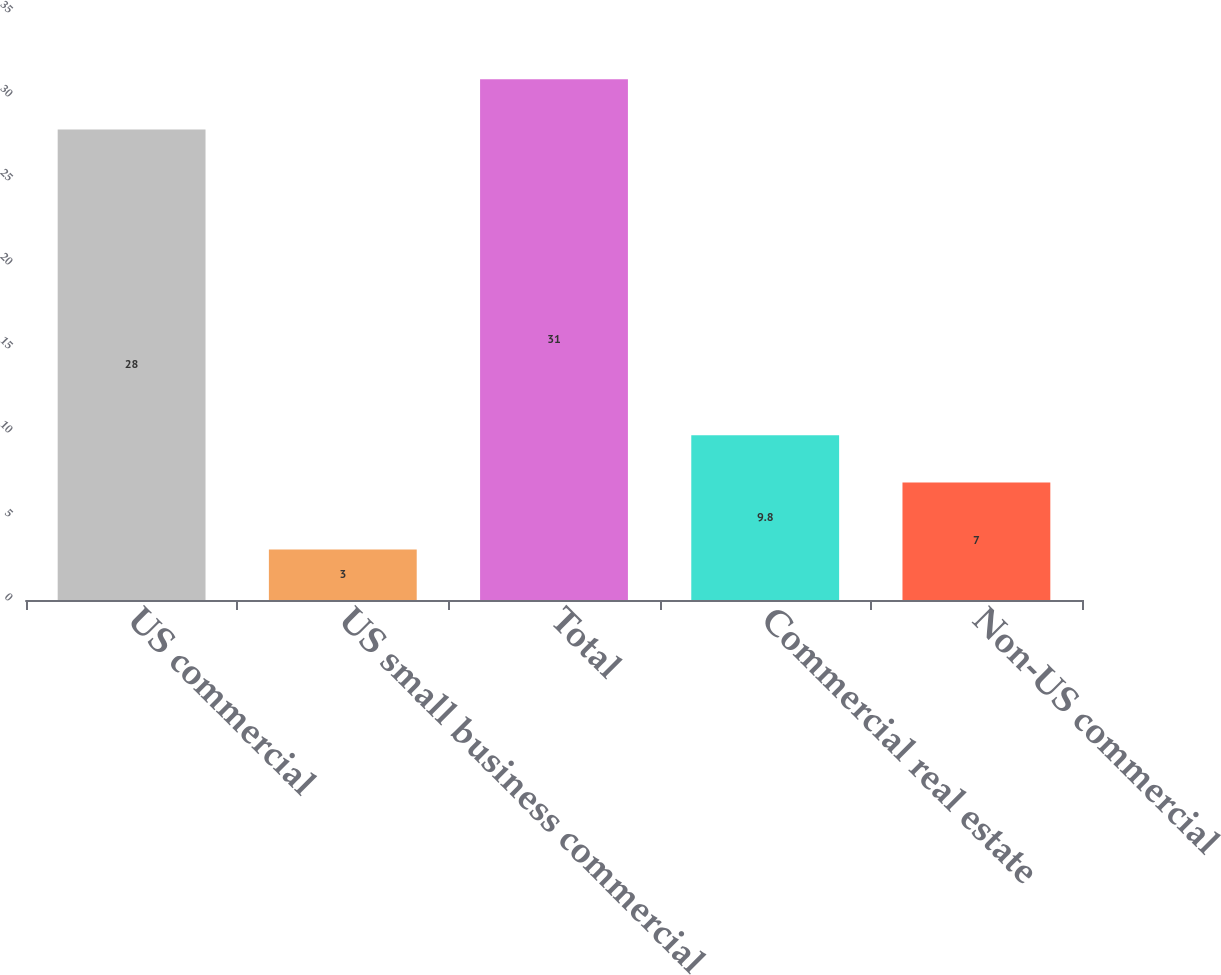<chart> <loc_0><loc_0><loc_500><loc_500><bar_chart><fcel>US commercial<fcel>US small business commercial<fcel>Total<fcel>Commercial real estate<fcel>Non-US commercial<nl><fcel>28<fcel>3<fcel>31<fcel>9.8<fcel>7<nl></chart> 